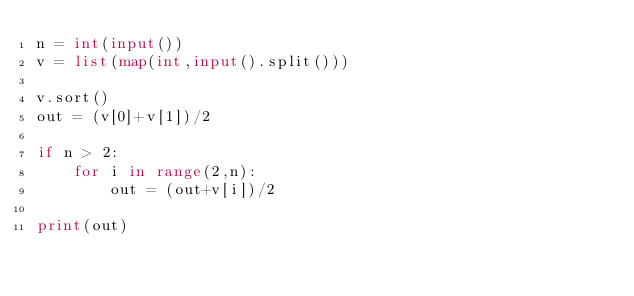<code> <loc_0><loc_0><loc_500><loc_500><_Python_>n = int(input())
v = list(map(int,input().split()))

v.sort()
out = (v[0]+v[1])/2

if n > 2:
    for i in range(2,n):
        out = (out+v[i])/2         

print(out)
    </code> 